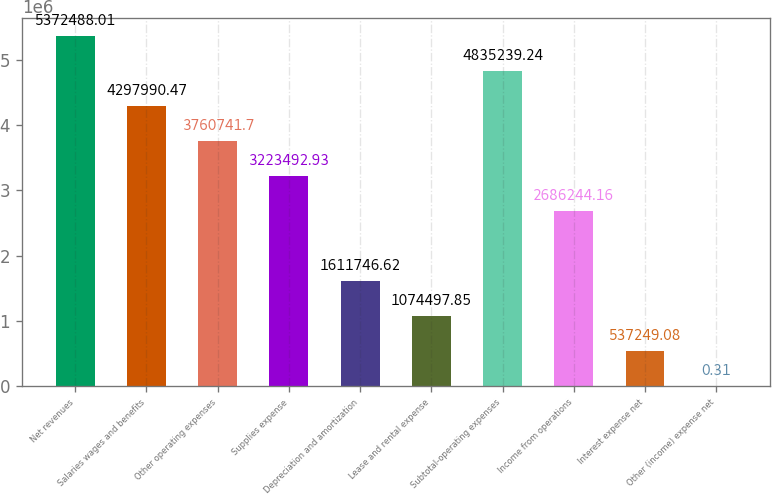<chart> <loc_0><loc_0><loc_500><loc_500><bar_chart><fcel>Net revenues<fcel>Salaries wages and benefits<fcel>Other operating expenses<fcel>Supplies expense<fcel>Depreciation and amortization<fcel>Lease and rental expense<fcel>Subtotal-operating expenses<fcel>Income from operations<fcel>Interest expense net<fcel>Other (income) expense net<nl><fcel>5.37249e+06<fcel>4.29799e+06<fcel>3.76074e+06<fcel>3.22349e+06<fcel>1.61175e+06<fcel>1.0745e+06<fcel>4.83524e+06<fcel>2.68624e+06<fcel>537249<fcel>0.31<nl></chart> 